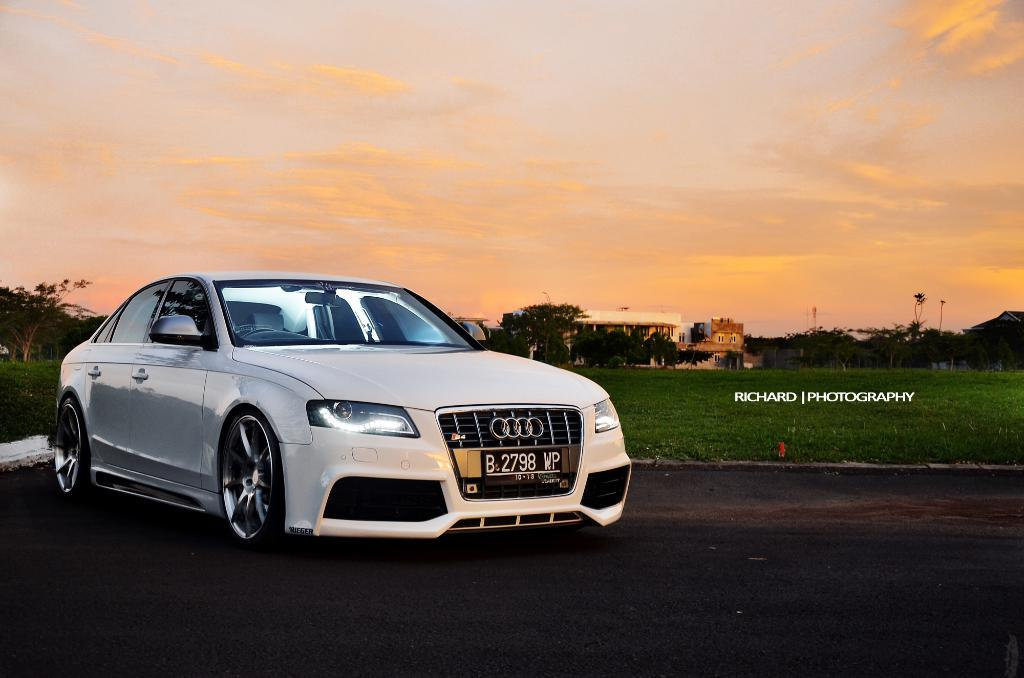What is the main subject of the image? There is a car on the road in the image. What can be seen on the ground at the back side of the image? There is grass on the surface at the back side of the image. What is visible in the background of the image? There are trees, buildings, and the sky visible in the background of the image. What type of match is being played in the image? There is no match being played in the image; it features a car on the road and various background elements. What kind of beam is supporting the buildings in the image? The image does not provide enough detail to determine the type of beams supporting the buildings. 